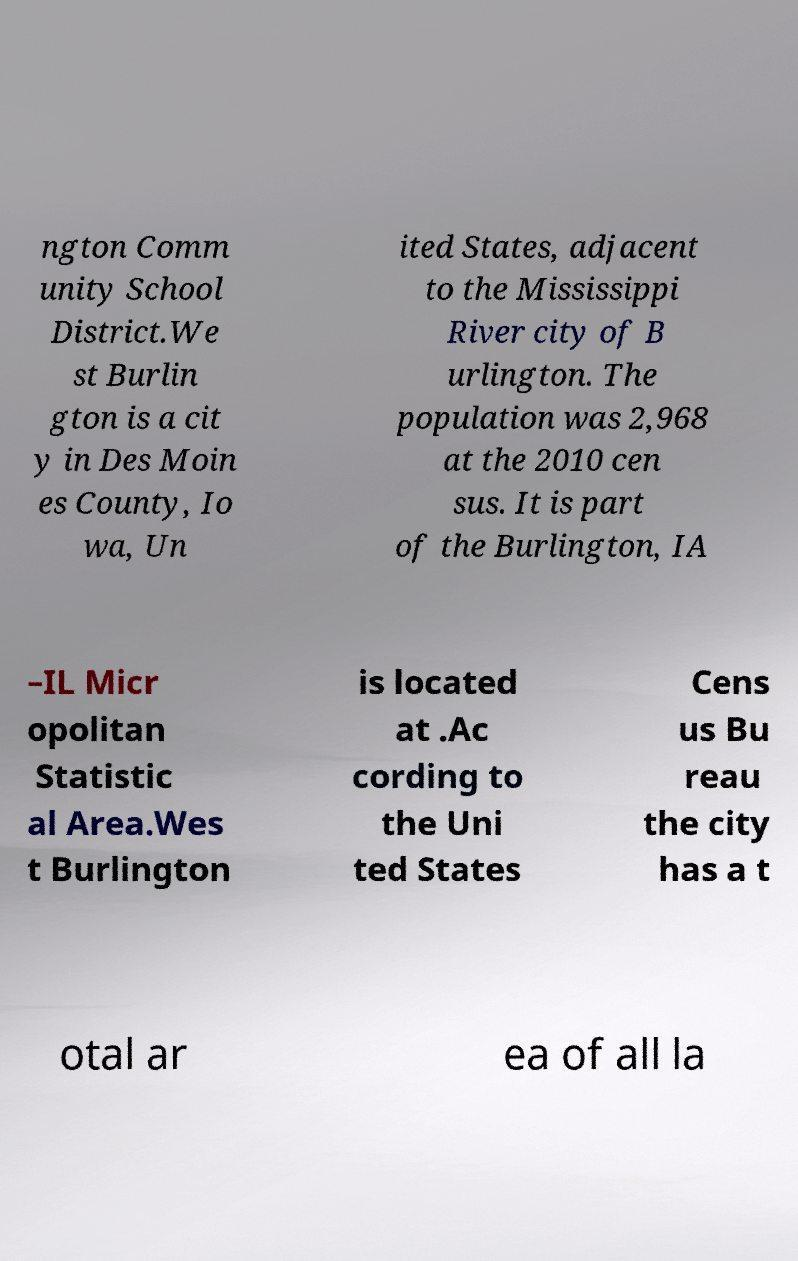Please read and relay the text visible in this image. What does it say? ngton Comm unity School District.We st Burlin gton is a cit y in Des Moin es County, Io wa, Un ited States, adjacent to the Mississippi River city of B urlington. The population was 2,968 at the 2010 cen sus. It is part of the Burlington, IA –IL Micr opolitan Statistic al Area.Wes t Burlington is located at .Ac cording to the Uni ted States Cens us Bu reau the city has a t otal ar ea of all la 